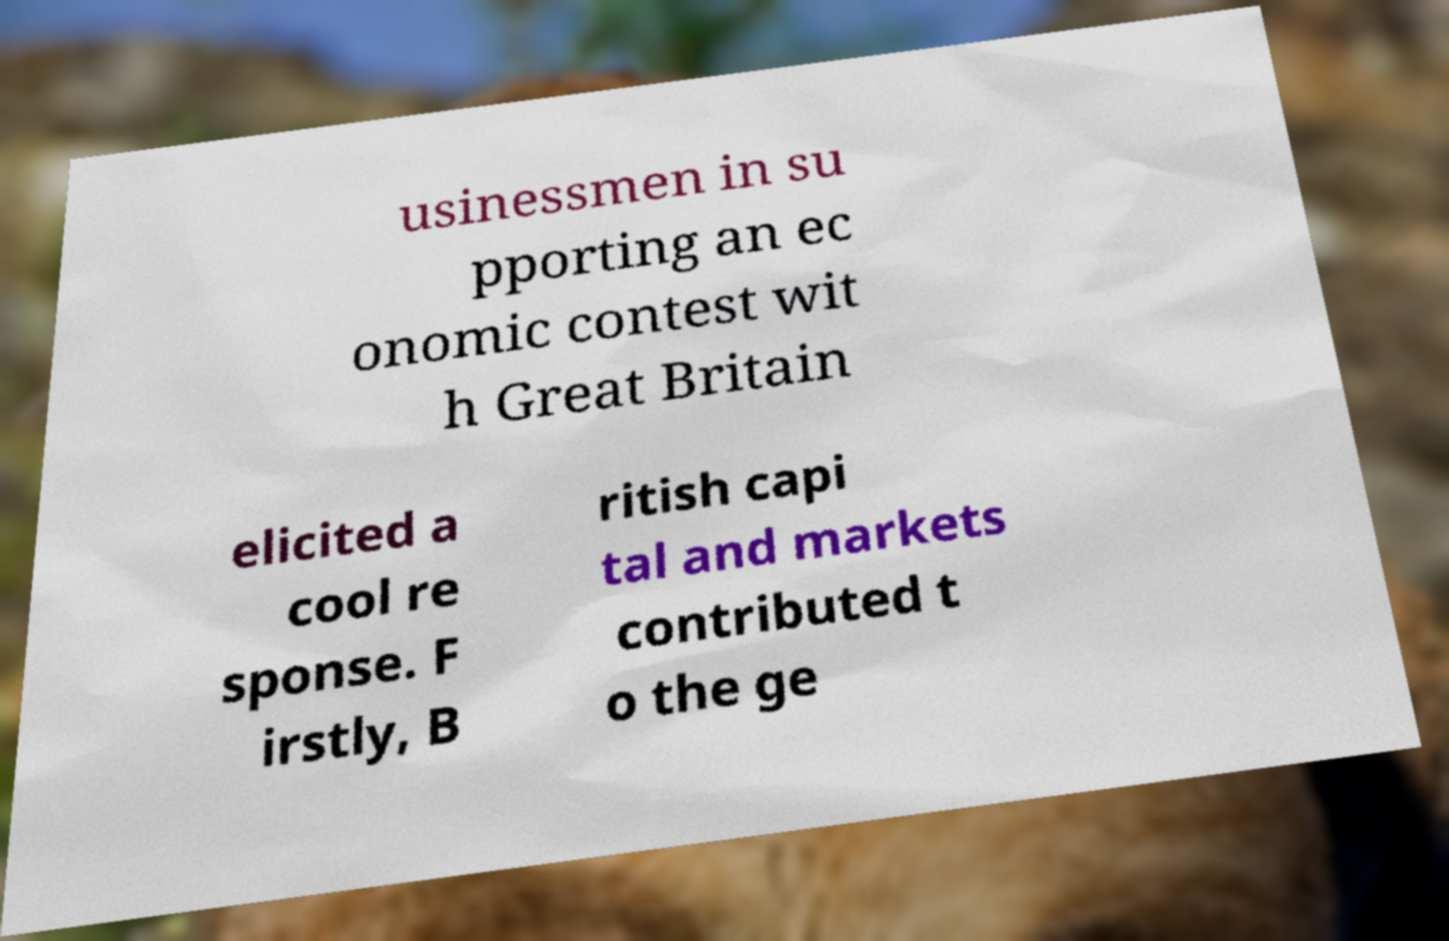Please identify and transcribe the text found in this image. usinessmen in su pporting an ec onomic contest wit h Great Britain elicited a cool re sponse. F irstly, B ritish capi tal and markets contributed t o the ge 